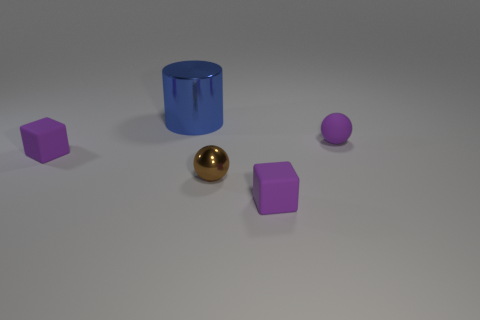Are there more small matte blocks than brown metal spheres?
Your answer should be compact. Yes. Are there more small rubber blocks that are behind the brown thing than tiny brown spheres that are behind the big metal thing?
Give a very brief answer. Yes. There is a object that is both on the left side of the small shiny sphere and in front of the big metal cylinder; what size is it?
Keep it short and to the point. Small. How many purple objects are the same size as the purple sphere?
Your answer should be very brief. 2. There is a tiny purple rubber thing left of the large object; is its shape the same as the big thing?
Your answer should be compact. No. Are there fewer small brown spheres behind the small brown metal thing than purple matte things?
Provide a short and direct response. Yes. Are there any other small things that have the same color as the small metallic thing?
Offer a very short reply. No. There is a tiny brown object; is its shape the same as the small purple rubber object that is on the left side of the large metallic cylinder?
Your response must be concise. No. Are there any big objects that have the same material as the cylinder?
Your response must be concise. No. There is a large blue cylinder behind the purple matte block in front of the tiny brown ball; is there a small purple rubber block behind it?
Ensure brevity in your answer.  No. 